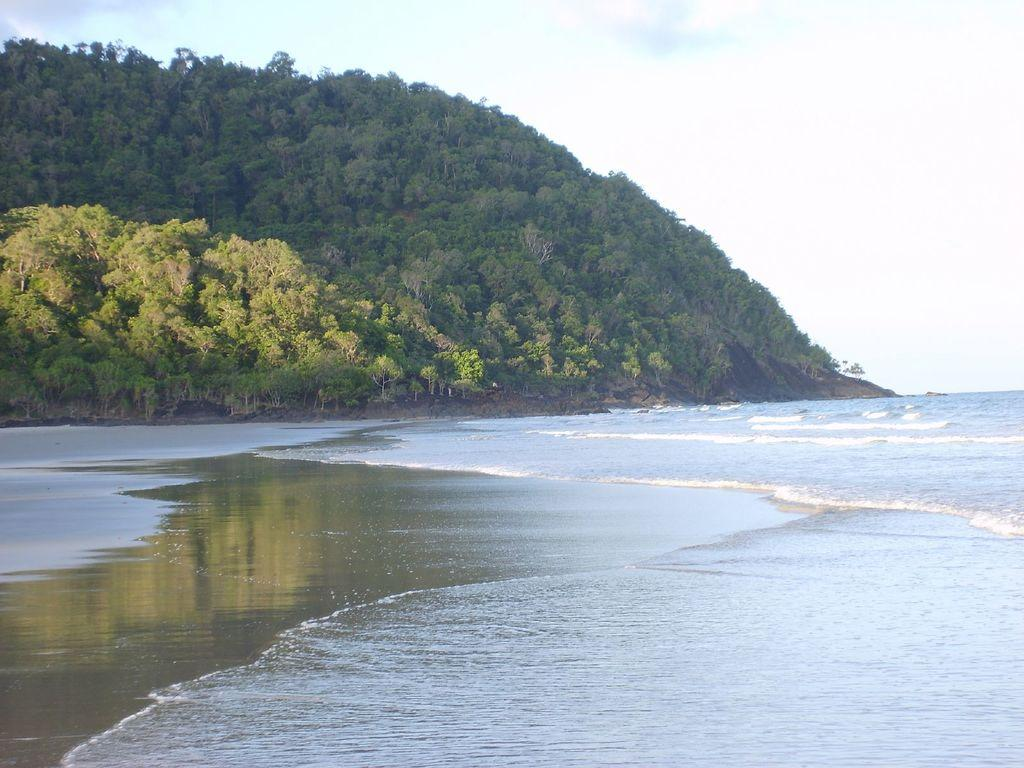What type of natural feature is visible in the image? There is a river in the image. What can be seen at the bottom of the river? Water is present at the bottom of the river. What is located in the background of the image? There is a hill in the background of the image. What type of vegetation is present on the hill? Trees are present on the hill. What is visible at the top of the image? The sky is visible at the top of the image. Can you see the person's smile on the page in the image? There is no person or page present in the image; it features a river, water, a hill, trees, and the sky. 